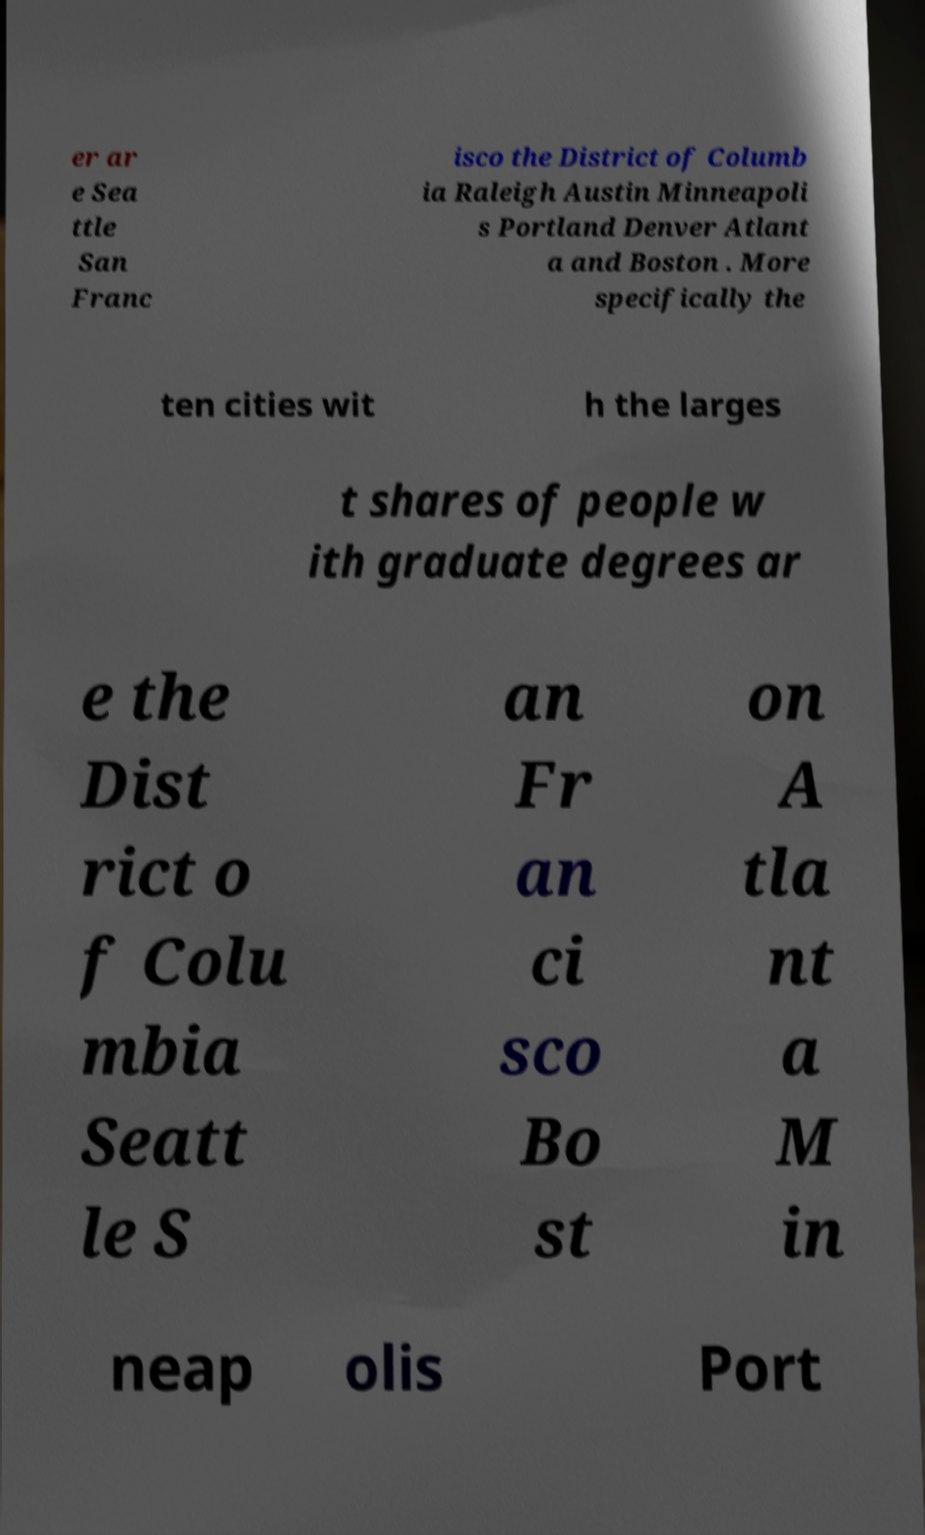Could you assist in decoding the text presented in this image and type it out clearly? er ar e Sea ttle San Franc isco the District of Columb ia Raleigh Austin Minneapoli s Portland Denver Atlant a and Boston . More specifically the ten cities wit h the larges t shares of people w ith graduate degrees ar e the Dist rict o f Colu mbia Seatt le S an Fr an ci sco Bo st on A tla nt a M in neap olis Port 